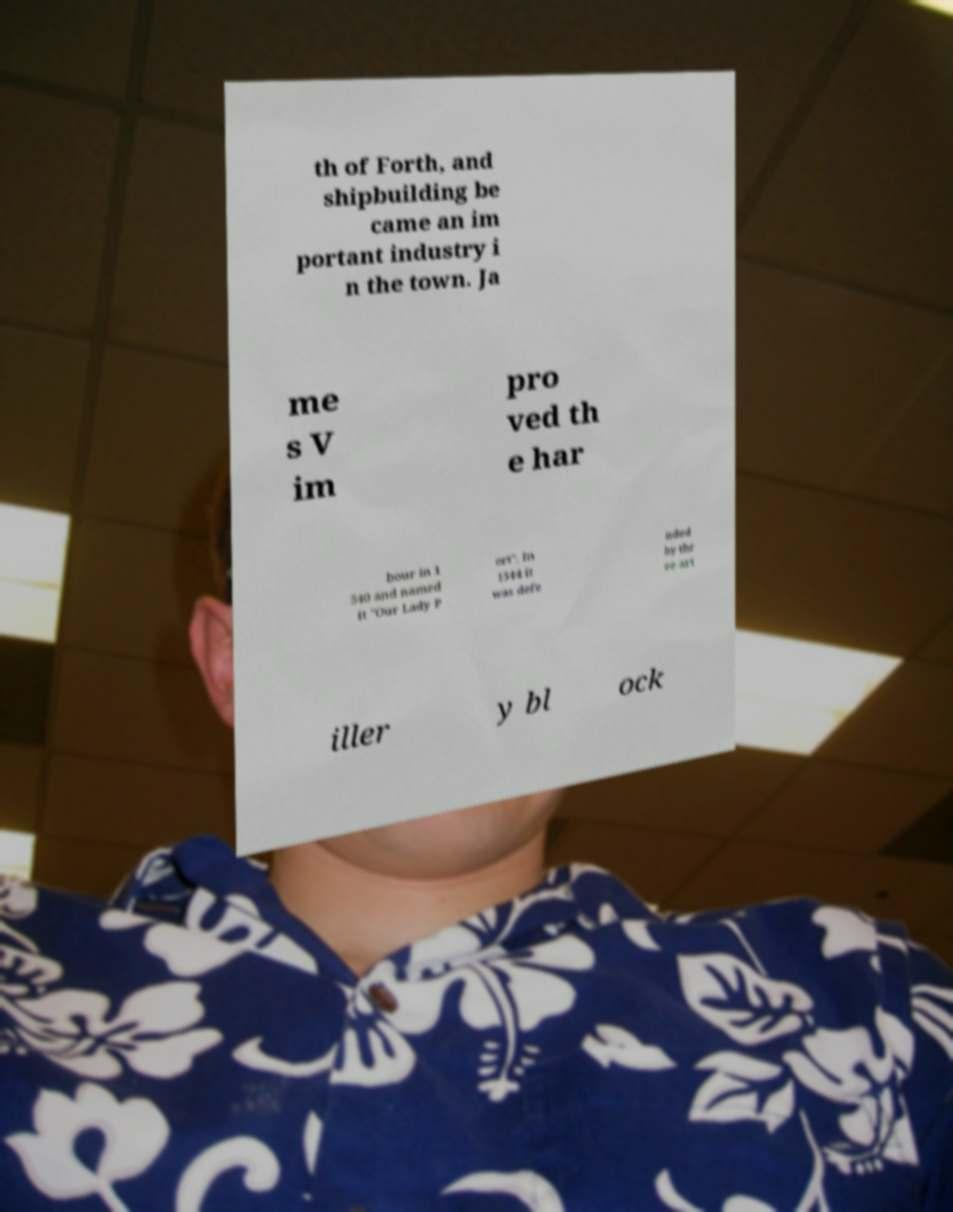Can you read and provide the text displayed in the image?This photo seems to have some interesting text. Can you extract and type it out for me? th of Forth, and shipbuilding be came an im portant industry i n the town. Ja me s V im pro ved th e har bour in 1 540 and named it "Our Lady P ort". In 1544 it was defe nded by thr ee art iller y bl ock 